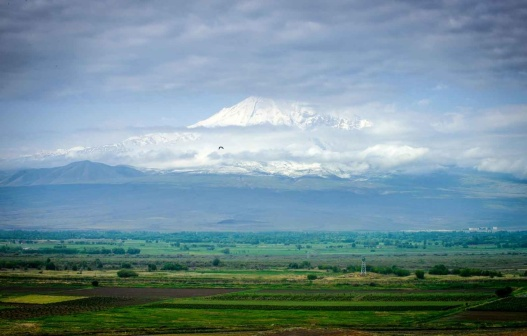Can you imagine what kind of wildlife might inhabit this landscape? Given the diverse features of the landscape, a variety of wildlife could thrive here. In the mountainous regions, one might find mountain goats or snow leopards, adept at navigating the snowy and rocky terrains. Meanwhile, the verdant valleys could serve as home to deer, rabbits, and numerous bird species. The scattered trees might be the perfect habitat for squirrels and various birdlife, making it a vibrant ecosystem. 